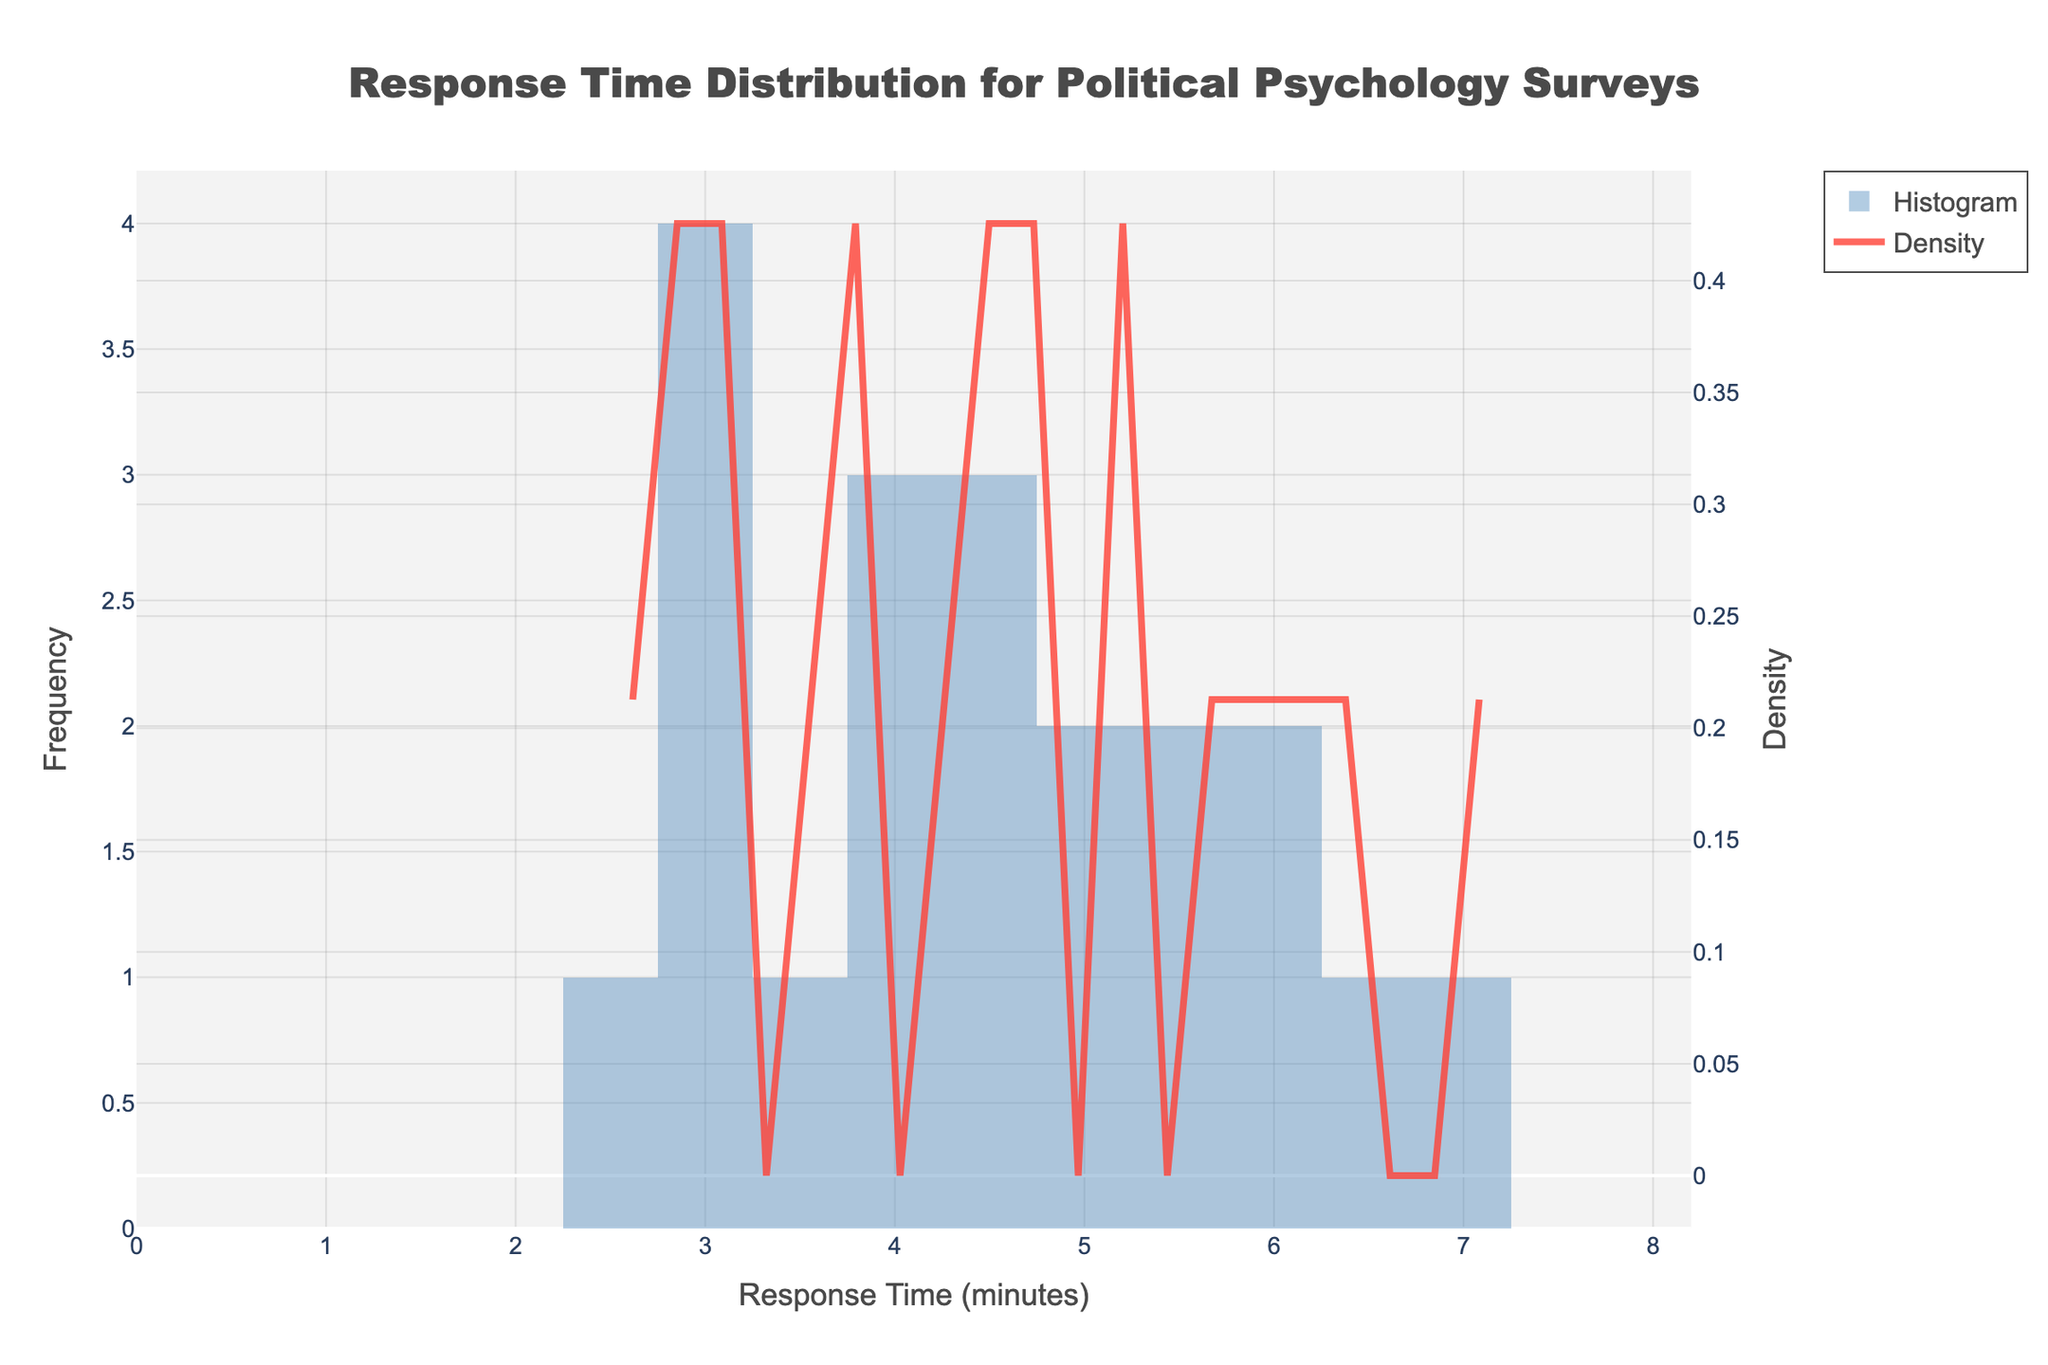What is the title of the figure? The title is located at the top of the figure and describes what the visualization represents. In this case, it is "Response Time Distribution for Political Psychology Surveys".
Answer: Response Time Distribution for Political Psychology Surveys What is the x-axis label? The x-axis label is displayed horizontally below the x-axis and indicates what the horizontal axis represents. Here, it’s labeled as "Response Time (minutes)".
Answer: Response Time (minutes) What color represents the histogram bars? The color of the histogram bars is visually distinguishable and is described as 'rgba(73, 133, 186, 0.6)', which appears as a shade of blue.
Answer: Blue What color represents the KDE curve? The KDE/density curve is shown in a specific color described as 'rgba(255, 65, 54, 0.8)', which appears as a shade of red.
Answer: Red How many bins are used in the histogram? The histogram bins can be counted manually or the number can be inferred if stated in the code/data. In this case, the code specifies `nbinsx=20`, indicating there are 20 bins.
Answer: 20 Between which range of response times does the most frequent bin fall? The most frequent bin is the tallest bar in the histogram. By checking the x-axis intervals, this bar represents the range of approximately 4 to 5 minutes.
Answer: 4 to 5 minutes Which axis represents density? The figure has a secondary y-axis, typically on the right, labeled as "Density". This axis is distinct from the primary y-axis on the left.
Answer: Right y-axis What is the maximum approximate density value on the KDE curve? This can be determined by looking at the highest point of the density curve on the secondary (right) y-axis. It appears to peak around 0.25.
Answer: 0.25 What is the range of response times depicted in the figure? The x-axis shows the range of response times from the smallest to the largest value. It spans approximately from 0 minutes to around 8 minutes.
Answer: 0 to 8 minutes Is the distribution of response times skewed? If so, in which direction? The distribution's skewness can be inferred from the histogram and KDE curve. It appears to have a longer tail on the right side, indicating it is right-skewed.
Answer: Right-skewed 